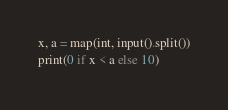Convert code to text. <code><loc_0><loc_0><loc_500><loc_500><_Python_>x, a = map(int, input().split())
print(0 if x < a else 10)</code> 